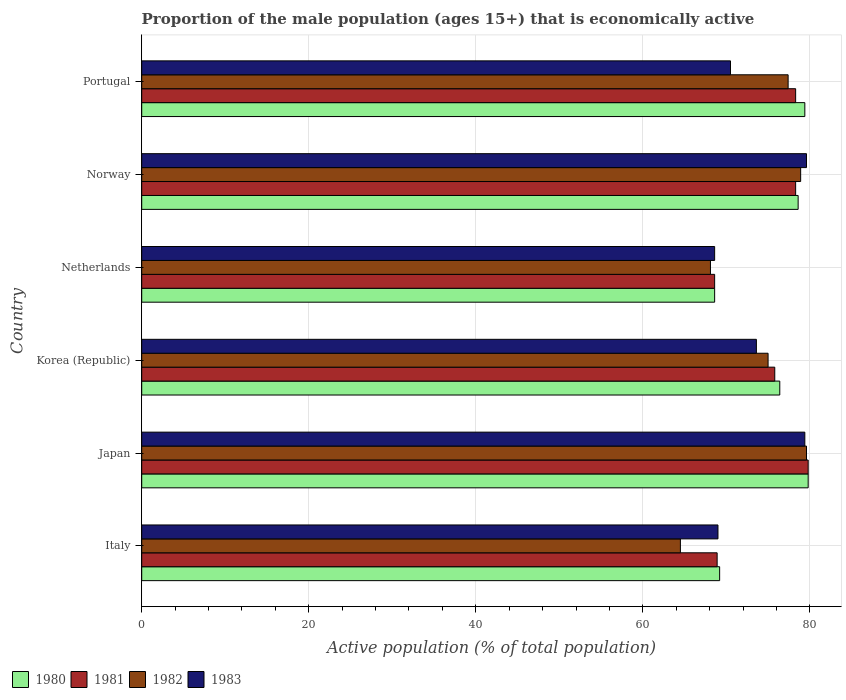How many different coloured bars are there?
Ensure brevity in your answer.  4. Are the number of bars on each tick of the Y-axis equal?
Give a very brief answer. Yes. How many bars are there on the 5th tick from the top?
Offer a terse response. 4. How many bars are there on the 1st tick from the bottom?
Offer a very short reply. 4. What is the label of the 6th group of bars from the top?
Offer a terse response. Italy. In how many cases, is the number of bars for a given country not equal to the number of legend labels?
Provide a succinct answer. 0. What is the proportion of the male population that is economically active in 1980 in Japan?
Ensure brevity in your answer.  79.8. Across all countries, what is the maximum proportion of the male population that is economically active in 1983?
Provide a short and direct response. 79.6. Across all countries, what is the minimum proportion of the male population that is economically active in 1983?
Your answer should be compact. 68.6. In which country was the proportion of the male population that is economically active in 1982 maximum?
Your answer should be compact. Japan. What is the total proportion of the male population that is economically active in 1983 in the graph?
Offer a terse response. 440.7. What is the difference between the proportion of the male population that is economically active in 1982 in Italy and that in Portugal?
Provide a short and direct response. -12.9. What is the difference between the proportion of the male population that is economically active in 1983 in Korea (Republic) and the proportion of the male population that is economically active in 1982 in Netherlands?
Offer a terse response. 5.5. What is the average proportion of the male population that is economically active in 1980 per country?
Make the answer very short. 75.33. What is the difference between the proportion of the male population that is economically active in 1983 and proportion of the male population that is economically active in 1980 in Portugal?
Make the answer very short. -8.9. In how many countries, is the proportion of the male population that is economically active in 1983 greater than 44 %?
Your answer should be very brief. 6. What is the ratio of the proportion of the male population that is economically active in 1981 in Korea (Republic) to that in Portugal?
Make the answer very short. 0.97. What is the difference between the highest and the second highest proportion of the male population that is economically active in 1980?
Ensure brevity in your answer.  0.4. What is the difference between the highest and the lowest proportion of the male population that is economically active in 1983?
Provide a short and direct response. 11. Is it the case that in every country, the sum of the proportion of the male population that is economically active in 1982 and proportion of the male population that is economically active in 1981 is greater than the sum of proportion of the male population that is economically active in 1983 and proportion of the male population that is economically active in 1980?
Your response must be concise. No. What does the 4th bar from the top in Netherlands represents?
Offer a terse response. 1980. Are all the bars in the graph horizontal?
Ensure brevity in your answer.  Yes. Does the graph contain any zero values?
Provide a succinct answer. No. Does the graph contain grids?
Ensure brevity in your answer.  Yes. Where does the legend appear in the graph?
Provide a short and direct response. Bottom left. What is the title of the graph?
Your answer should be compact. Proportion of the male population (ages 15+) that is economically active. Does "2010" appear as one of the legend labels in the graph?
Make the answer very short. No. What is the label or title of the X-axis?
Your answer should be very brief. Active population (% of total population). What is the Active population (% of total population) of 1980 in Italy?
Make the answer very short. 69.2. What is the Active population (% of total population) in 1981 in Italy?
Offer a terse response. 68.9. What is the Active population (% of total population) of 1982 in Italy?
Give a very brief answer. 64.5. What is the Active population (% of total population) of 1980 in Japan?
Provide a short and direct response. 79.8. What is the Active population (% of total population) in 1981 in Japan?
Your response must be concise. 79.8. What is the Active population (% of total population) of 1982 in Japan?
Ensure brevity in your answer.  79.6. What is the Active population (% of total population) in 1983 in Japan?
Make the answer very short. 79.4. What is the Active population (% of total population) in 1980 in Korea (Republic)?
Give a very brief answer. 76.4. What is the Active population (% of total population) of 1981 in Korea (Republic)?
Give a very brief answer. 75.8. What is the Active population (% of total population) in 1983 in Korea (Republic)?
Offer a terse response. 73.6. What is the Active population (% of total population) in 1980 in Netherlands?
Your answer should be compact. 68.6. What is the Active population (% of total population) in 1981 in Netherlands?
Your response must be concise. 68.6. What is the Active population (% of total population) in 1982 in Netherlands?
Offer a terse response. 68.1. What is the Active population (% of total population) of 1983 in Netherlands?
Offer a very short reply. 68.6. What is the Active population (% of total population) in 1980 in Norway?
Your answer should be compact. 78.6. What is the Active population (% of total population) of 1981 in Norway?
Offer a terse response. 78.3. What is the Active population (% of total population) in 1982 in Norway?
Your response must be concise. 78.9. What is the Active population (% of total population) in 1983 in Norway?
Offer a very short reply. 79.6. What is the Active population (% of total population) of 1980 in Portugal?
Your answer should be very brief. 79.4. What is the Active population (% of total population) in 1981 in Portugal?
Keep it short and to the point. 78.3. What is the Active population (% of total population) in 1982 in Portugal?
Provide a succinct answer. 77.4. What is the Active population (% of total population) of 1983 in Portugal?
Provide a succinct answer. 70.5. Across all countries, what is the maximum Active population (% of total population) of 1980?
Your response must be concise. 79.8. Across all countries, what is the maximum Active population (% of total population) of 1981?
Keep it short and to the point. 79.8. Across all countries, what is the maximum Active population (% of total population) of 1982?
Provide a succinct answer. 79.6. Across all countries, what is the maximum Active population (% of total population) of 1983?
Keep it short and to the point. 79.6. Across all countries, what is the minimum Active population (% of total population) in 1980?
Give a very brief answer. 68.6. Across all countries, what is the minimum Active population (% of total population) in 1981?
Ensure brevity in your answer.  68.6. Across all countries, what is the minimum Active population (% of total population) of 1982?
Provide a succinct answer. 64.5. Across all countries, what is the minimum Active population (% of total population) of 1983?
Ensure brevity in your answer.  68.6. What is the total Active population (% of total population) of 1980 in the graph?
Your answer should be very brief. 452. What is the total Active population (% of total population) in 1981 in the graph?
Provide a succinct answer. 449.7. What is the total Active population (% of total population) of 1982 in the graph?
Make the answer very short. 443.5. What is the total Active population (% of total population) of 1983 in the graph?
Offer a very short reply. 440.7. What is the difference between the Active population (% of total population) in 1982 in Italy and that in Japan?
Make the answer very short. -15.1. What is the difference between the Active population (% of total population) of 1983 in Italy and that in Japan?
Offer a terse response. -10.4. What is the difference between the Active population (% of total population) in 1983 in Italy and that in Korea (Republic)?
Offer a terse response. -4.6. What is the difference between the Active population (% of total population) in 1982 in Italy and that in Netherlands?
Offer a terse response. -3.6. What is the difference between the Active population (% of total population) in 1981 in Italy and that in Norway?
Provide a short and direct response. -9.4. What is the difference between the Active population (% of total population) in 1982 in Italy and that in Norway?
Ensure brevity in your answer.  -14.4. What is the difference between the Active population (% of total population) in 1981 in Italy and that in Portugal?
Your answer should be very brief. -9.4. What is the difference between the Active population (% of total population) of 1983 in Italy and that in Portugal?
Make the answer very short. -1.5. What is the difference between the Active population (% of total population) in 1980 in Japan and that in Korea (Republic)?
Offer a very short reply. 3.4. What is the difference between the Active population (% of total population) in 1981 in Japan and that in Korea (Republic)?
Offer a terse response. 4. What is the difference between the Active population (% of total population) in 1982 in Japan and that in Norway?
Ensure brevity in your answer.  0.7. What is the difference between the Active population (% of total population) in 1983 in Japan and that in Norway?
Your answer should be compact. -0.2. What is the difference between the Active population (% of total population) in 1981 in Japan and that in Portugal?
Keep it short and to the point. 1.5. What is the difference between the Active population (% of total population) in 1980 in Korea (Republic) and that in Netherlands?
Your response must be concise. 7.8. What is the difference between the Active population (% of total population) in 1982 in Korea (Republic) and that in Netherlands?
Provide a short and direct response. 6.9. What is the difference between the Active population (% of total population) of 1981 in Netherlands and that in Norway?
Keep it short and to the point. -9.7. What is the difference between the Active population (% of total population) in 1982 in Netherlands and that in Portugal?
Your answer should be compact. -9.3. What is the difference between the Active population (% of total population) in 1983 in Netherlands and that in Portugal?
Make the answer very short. -1.9. What is the difference between the Active population (% of total population) of 1980 in Norway and that in Portugal?
Give a very brief answer. -0.8. What is the difference between the Active population (% of total population) of 1981 in Norway and that in Portugal?
Provide a succinct answer. 0. What is the difference between the Active population (% of total population) in 1982 in Norway and that in Portugal?
Your answer should be compact. 1.5. What is the difference between the Active population (% of total population) in 1982 in Italy and the Active population (% of total population) in 1983 in Japan?
Ensure brevity in your answer.  -14.9. What is the difference between the Active population (% of total population) in 1980 in Italy and the Active population (% of total population) in 1981 in Korea (Republic)?
Keep it short and to the point. -6.6. What is the difference between the Active population (% of total population) in 1981 in Italy and the Active population (% of total population) in 1983 in Korea (Republic)?
Your answer should be compact. -4.7. What is the difference between the Active population (% of total population) in 1982 in Italy and the Active population (% of total population) in 1983 in Korea (Republic)?
Give a very brief answer. -9.1. What is the difference between the Active population (% of total population) of 1981 in Italy and the Active population (% of total population) of 1982 in Netherlands?
Offer a very short reply. 0.8. What is the difference between the Active population (% of total population) in 1982 in Italy and the Active population (% of total population) in 1983 in Netherlands?
Your response must be concise. -4.1. What is the difference between the Active population (% of total population) of 1980 in Italy and the Active population (% of total population) of 1981 in Norway?
Make the answer very short. -9.1. What is the difference between the Active population (% of total population) of 1980 in Italy and the Active population (% of total population) of 1982 in Norway?
Your response must be concise. -9.7. What is the difference between the Active population (% of total population) of 1980 in Italy and the Active population (% of total population) of 1983 in Norway?
Give a very brief answer. -10.4. What is the difference between the Active population (% of total population) of 1982 in Italy and the Active population (% of total population) of 1983 in Norway?
Give a very brief answer. -15.1. What is the difference between the Active population (% of total population) in 1980 in Italy and the Active population (% of total population) in 1982 in Portugal?
Your answer should be compact. -8.2. What is the difference between the Active population (% of total population) in 1980 in Italy and the Active population (% of total population) in 1983 in Portugal?
Provide a succinct answer. -1.3. What is the difference between the Active population (% of total population) in 1982 in Italy and the Active population (% of total population) in 1983 in Portugal?
Your response must be concise. -6. What is the difference between the Active population (% of total population) of 1980 in Japan and the Active population (% of total population) of 1982 in Korea (Republic)?
Provide a short and direct response. 4.8. What is the difference between the Active population (% of total population) in 1980 in Japan and the Active population (% of total population) in 1983 in Korea (Republic)?
Offer a very short reply. 6.2. What is the difference between the Active population (% of total population) of 1981 in Japan and the Active population (% of total population) of 1982 in Korea (Republic)?
Offer a very short reply. 4.8. What is the difference between the Active population (% of total population) in 1980 in Japan and the Active population (% of total population) in 1983 in Netherlands?
Your response must be concise. 11.2. What is the difference between the Active population (% of total population) of 1981 in Japan and the Active population (% of total population) of 1982 in Netherlands?
Offer a very short reply. 11.7. What is the difference between the Active population (% of total population) in 1981 in Japan and the Active population (% of total population) in 1983 in Netherlands?
Provide a short and direct response. 11.2. What is the difference between the Active population (% of total population) in 1980 in Japan and the Active population (% of total population) in 1981 in Norway?
Give a very brief answer. 1.5. What is the difference between the Active population (% of total population) in 1980 in Japan and the Active population (% of total population) in 1982 in Norway?
Provide a short and direct response. 0.9. What is the difference between the Active population (% of total population) of 1980 in Japan and the Active population (% of total population) of 1983 in Norway?
Offer a very short reply. 0.2. What is the difference between the Active population (% of total population) of 1981 in Japan and the Active population (% of total population) of 1983 in Norway?
Ensure brevity in your answer.  0.2. What is the difference between the Active population (% of total population) in 1980 in Japan and the Active population (% of total population) in 1981 in Portugal?
Give a very brief answer. 1.5. What is the difference between the Active population (% of total population) of 1980 in Japan and the Active population (% of total population) of 1982 in Portugal?
Keep it short and to the point. 2.4. What is the difference between the Active population (% of total population) in 1980 in Japan and the Active population (% of total population) in 1983 in Portugal?
Keep it short and to the point. 9.3. What is the difference between the Active population (% of total population) of 1981 in Japan and the Active population (% of total population) of 1982 in Portugal?
Keep it short and to the point. 2.4. What is the difference between the Active population (% of total population) in 1981 in Japan and the Active population (% of total population) in 1983 in Portugal?
Give a very brief answer. 9.3. What is the difference between the Active population (% of total population) of 1980 in Korea (Republic) and the Active population (% of total population) of 1981 in Netherlands?
Give a very brief answer. 7.8. What is the difference between the Active population (% of total population) of 1981 in Korea (Republic) and the Active population (% of total population) of 1982 in Netherlands?
Your answer should be very brief. 7.7. What is the difference between the Active population (% of total population) of 1981 in Korea (Republic) and the Active population (% of total population) of 1983 in Netherlands?
Your answer should be very brief. 7.2. What is the difference between the Active population (% of total population) in 1982 in Korea (Republic) and the Active population (% of total population) in 1983 in Netherlands?
Provide a short and direct response. 6.4. What is the difference between the Active population (% of total population) of 1981 in Korea (Republic) and the Active population (% of total population) of 1983 in Norway?
Provide a short and direct response. -3.8. What is the difference between the Active population (% of total population) in 1980 in Korea (Republic) and the Active population (% of total population) in 1981 in Portugal?
Your answer should be compact. -1.9. What is the difference between the Active population (% of total population) of 1980 in Korea (Republic) and the Active population (% of total population) of 1982 in Portugal?
Your response must be concise. -1. What is the difference between the Active population (% of total population) of 1982 in Korea (Republic) and the Active population (% of total population) of 1983 in Portugal?
Give a very brief answer. 4.5. What is the difference between the Active population (% of total population) in 1980 in Netherlands and the Active population (% of total population) in 1982 in Norway?
Ensure brevity in your answer.  -10.3. What is the difference between the Active population (% of total population) of 1980 in Netherlands and the Active population (% of total population) of 1983 in Norway?
Give a very brief answer. -11. What is the difference between the Active population (% of total population) in 1981 in Netherlands and the Active population (% of total population) in 1983 in Norway?
Provide a succinct answer. -11. What is the difference between the Active population (% of total population) in 1980 in Netherlands and the Active population (% of total population) in 1982 in Portugal?
Offer a very short reply. -8.8. What is the difference between the Active population (% of total population) of 1981 in Netherlands and the Active population (% of total population) of 1983 in Portugal?
Give a very brief answer. -1.9. What is the difference between the Active population (% of total population) in 1980 in Norway and the Active population (% of total population) in 1983 in Portugal?
Your answer should be very brief. 8.1. What is the difference between the Active population (% of total population) of 1981 in Norway and the Active population (% of total population) of 1983 in Portugal?
Keep it short and to the point. 7.8. What is the difference between the Active population (% of total population) of 1982 in Norway and the Active population (% of total population) of 1983 in Portugal?
Provide a short and direct response. 8.4. What is the average Active population (% of total population) of 1980 per country?
Your answer should be very brief. 75.33. What is the average Active population (% of total population) in 1981 per country?
Offer a terse response. 74.95. What is the average Active population (% of total population) of 1982 per country?
Your answer should be compact. 73.92. What is the average Active population (% of total population) of 1983 per country?
Your answer should be compact. 73.45. What is the difference between the Active population (% of total population) of 1980 and Active population (% of total population) of 1982 in Italy?
Your answer should be very brief. 4.7. What is the difference between the Active population (% of total population) of 1980 and Active population (% of total population) of 1983 in Italy?
Your response must be concise. 0.2. What is the difference between the Active population (% of total population) in 1981 and Active population (% of total population) in 1982 in Italy?
Offer a very short reply. 4.4. What is the difference between the Active population (% of total population) of 1982 and Active population (% of total population) of 1983 in Italy?
Keep it short and to the point. -4.5. What is the difference between the Active population (% of total population) in 1981 and Active population (% of total population) in 1982 in Japan?
Give a very brief answer. 0.2. What is the difference between the Active population (% of total population) of 1982 and Active population (% of total population) of 1983 in Japan?
Give a very brief answer. 0.2. What is the difference between the Active population (% of total population) in 1980 and Active population (% of total population) in 1981 in Korea (Republic)?
Ensure brevity in your answer.  0.6. What is the difference between the Active population (% of total population) of 1980 and Active population (% of total population) of 1982 in Korea (Republic)?
Offer a very short reply. 1.4. What is the difference between the Active population (% of total population) in 1980 and Active population (% of total population) in 1983 in Korea (Republic)?
Your answer should be compact. 2.8. What is the difference between the Active population (% of total population) in 1981 and Active population (% of total population) in 1983 in Korea (Republic)?
Offer a very short reply. 2.2. What is the difference between the Active population (% of total population) in 1982 and Active population (% of total population) in 1983 in Korea (Republic)?
Give a very brief answer. 1.4. What is the difference between the Active population (% of total population) in 1980 and Active population (% of total population) in 1983 in Netherlands?
Ensure brevity in your answer.  0. What is the difference between the Active population (% of total population) of 1982 and Active population (% of total population) of 1983 in Netherlands?
Your answer should be compact. -0.5. What is the difference between the Active population (% of total population) of 1980 and Active population (% of total population) of 1981 in Norway?
Ensure brevity in your answer.  0.3. What is the difference between the Active population (% of total population) in 1981 and Active population (% of total population) in 1982 in Norway?
Ensure brevity in your answer.  -0.6. What is the difference between the Active population (% of total population) of 1980 and Active population (% of total population) of 1981 in Portugal?
Your response must be concise. 1.1. What is the difference between the Active population (% of total population) in 1980 and Active population (% of total population) in 1982 in Portugal?
Your response must be concise. 2. What is the ratio of the Active population (% of total population) of 1980 in Italy to that in Japan?
Provide a succinct answer. 0.87. What is the ratio of the Active population (% of total population) in 1981 in Italy to that in Japan?
Provide a short and direct response. 0.86. What is the ratio of the Active population (% of total population) in 1982 in Italy to that in Japan?
Make the answer very short. 0.81. What is the ratio of the Active population (% of total population) in 1983 in Italy to that in Japan?
Offer a terse response. 0.87. What is the ratio of the Active population (% of total population) of 1980 in Italy to that in Korea (Republic)?
Your answer should be compact. 0.91. What is the ratio of the Active population (% of total population) in 1981 in Italy to that in Korea (Republic)?
Your answer should be very brief. 0.91. What is the ratio of the Active population (% of total population) in 1982 in Italy to that in Korea (Republic)?
Offer a terse response. 0.86. What is the ratio of the Active population (% of total population) in 1983 in Italy to that in Korea (Republic)?
Offer a terse response. 0.94. What is the ratio of the Active population (% of total population) of 1980 in Italy to that in Netherlands?
Offer a terse response. 1.01. What is the ratio of the Active population (% of total population) in 1982 in Italy to that in Netherlands?
Offer a very short reply. 0.95. What is the ratio of the Active population (% of total population) in 1983 in Italy to that in Netherlands?
Your response must be concise. 1.01. What is the ratio of the Active population (% of total population) in 1980 in Italy to that in Norway?
Provide a short and direct response. 0.88. What is the ratio of the Active population (% of total population) in 1981 in Italy to that in Norway?
Provide a succinct answer. 0.88. What is the ratio of the Active population (% of total population) of 1982 in Italy to that in Norway?
Your answer should be very brief. 0.82. What is the ratio of the Active population (% of total population) in 1983 in Italy to that in Norway?
Your answer should be compact. 0.87. What is the ratio of the Active population (% of total population) of 1980 in Italy to that in Portugal?
Make the answer very short. 0.87. What is the ratio of the Active population (% of total population) of 1981 in Italy to that in Portugal?
Your answer should be compact. 0.88. What is the ratio of the Active population (% of total population) in 1982 in Italy to that in Portugal?
Keep it short and to the point. 0.83. What is the ratio of the Active population (% of total population) in 1983 in Italy to that in Portugal?
Provide a succinct answer. 0.98. What is the ratio of the Active population (% of total population) in 1980 in Japan to that in Korea (Republic)?
Offer a terse response. 1.04. What is the ratio of the Active population (% of total population) in 1981 in Japan to that in Korea (Republic)?
Provide a succinct answer. 1.05. What is the ratio of the Active population (% of total population) of 1982 in Japan to that in Korea (Republic)?
Offer a very short reply. 1.06. What is the ratio of the Active population (% of total population) in 1983 in Japan to that in Korea (Republic)?
Ensure brevity in your answer.  1.08. What is the ratio of the Active population (% of total population) in 1980 in Japan to that in Netherlands?
Provide a short and direct response. 1.16. What is the ratio of the Active population (% of total population) in 1981 in Japan to that in Netherlands?
Provide a short and direct response. 1.16. What is the ratio of the Active population (% of total population) of 1982 in Japan to that in Netherlands?
Offer a very short reply. 1.17. What is the ratio of the Active population (% of total population) in 1983 in Japan to that in Netherlands?
Offer a terse response. 1.16. What is the ratio of the Active population (% of total population) of 1980 in Japan to that in Norway?
Your response must be concise. 1.02. What is the ratio of the Active population (% of total population) in 1981 in Japan to that in Norway?
Give a very brief answer. 1.02. What is the ratio of the Active population (% of total population) in 1982 in Japan to that in Norway?
Offer a very short reply. 1.01. What is the ratio of the Active population (% of total population) in 1983 in Japan to that in Norway?
Make the answer very short. 1. What is the ratio of the Active population (% of total population) of 1980 in Japan to that in Portugal?
Your answer should be very brief. 1. What is the ratio of the Active population (% of total population) of 1981 in Japan to that in Portugal?
Provide a short and direct response. 1.02. What is the ratio of the Active population (% of total population) in 1982 in Japan to that in Portugal?
Your answer should be compact. 1.03. What is the ratio of the Active population (% of total population) in 1983 in Japan to that in Portugal?
Keep it short and to the point. 1.13. What is the ratio of the Active population (% of total population) of 1980 in Korea (Republic) to that in Netherlands?
Provide a succinct answer. 1.11. What is the ratio of the Active population (% of total population) of 1981 in Korea (Republic) to that in Netherlands?
Make the answer very short. 1.1. What is the ratio of the Active population (% of total population) of 1982 in Korea (Republic) to that in Netherlands?
Your answer should be compact. 1.1. What is the ratio of the Active population (% of total population) in 1983 in Korea (Republic) to that in Netherlands?
Make the answer very short. 1.07. What is the ratio of the Active population (% of total population) of 1980 in Korea (Republic) to that in Norway?
Your answer should be very brief. 0.97. What is the ratio of the Active population (% of total population) of 1981 in Korea (Republic) to that in Norway?
Make the answer very short. 0.97. What is the ratio of the Active population (% of total population) of 1982 in Korea (Republic) to that in Norway?
Offer a terse response. 0.95. What is the ratio of the Active population (% of total population) of 1983 in Korea (Republic) to that in Norway?
Provide a short and direct response. 0.92. What is the ratio of the Active population (% of total population) of 1980 in Korea (Republic) to that in Portugal?
Keep it short and to the point. 0.96. What is the ratio of the Active population (% of total population) of 1981 in Korea (Republic) to that in Portugal?
Provide a short and direct response. 0.97. What is the ratio of the Active population (% of total population) of 1982 in Korea (Republic) to that in Portugal?
Your answer should be very brief. 0.97. What is the ratio of the Active population (% of total population) in 1983 in Korea (Republic) to that in Portugal?
Make the answer very short. 1.04. What is the ratio of the Active population (% of total population) in 1980 in Netherlands to that in Norway?
Provide a short and direct response. 0.87. What is the ratio of the Active population (% of total population) in 1981 in Netherlands to that in Norway?
Keep it short and to the point. 0.88. What is the ratio of the Active population (% of total population) in 1982 in Netherlands to that in Norway?
Your response must be concise. 0.86. What is the ratio of the Active population (% of total population) of 1983 in Netherlands to that in Norway?
Your response must be concise. 0.86. What is the ratio of the Active population (% of total population) in 1980 in Netherlands to that in Portugal?
Offer a terse response. 0.86. What is the ratio of the Active population (% of total population) in 1981 in Netherlands to that in Portugal?
Your answer should be very brief. 0.88. What is the ratio of the Active population (% of total population) in 1982 in Netherlands to that in Portugal?
Your answer should be very brief. 0.88. What is the ratio of the Active population (% of total population) in 1982 in Norway to that in Portugal?
Give a very brief answer. 1.02. What is the ratio of the Active population (% of total population) of 1983 in Norway to that in Portugal?
Your answer should be compact. 1.13. What is the difference between the highest and the second highest Active population (% of total population) in 1980?
Keep it short and to the point. 0.4. What is the difference between the highest and the second highest Active population (% of total population) in 1981?
Keep it short and to the point. 1.5. What is the difference between the highest and the second highest Active population (% of total population) in 1982?
Your answer should be compact. 0.7. What is the difference between the highest and the second highest Active population (% of total population) in 1983?
Offer a terse response. 0.2. What is the difference between the highest and the lowest Active population (% of total population) of 1981?
Offer a very short reply. 11.2. What is the difference between the highest and the lowest Active population (% of total population) of 1982?
Offer a very short reply. 15.1. What is the difference between the highest and the lowest Active population (% of total population) of 1983?
Provide a short and direct response. 11. 